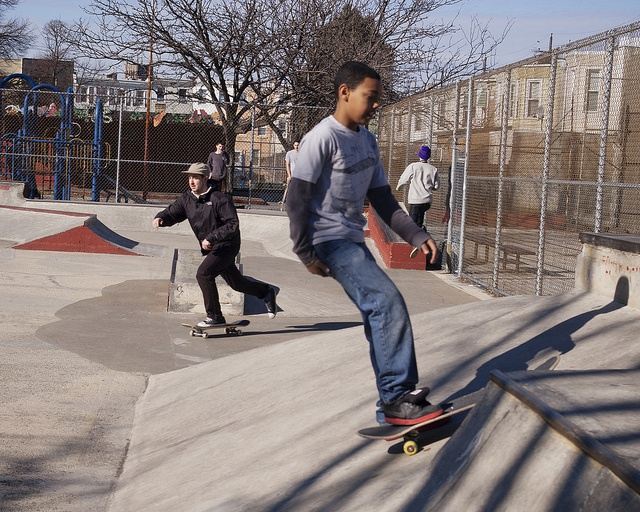Describe the objects in this image and their specific colors. I can see people in gray and black tones, people in gray and black tones, skateboard in gray, black, and darkgray tones, people in gray, lightgray, black, and darkgray tones, and people in gray, black, and maroon tones in this image. 